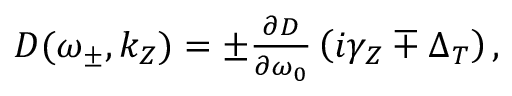<formula> <loc_0><loc_0><loc_500><loc_500>\begin{array} { r } { D ( \omega _ { \pm } , k _ { Z } ) = \pm \frac { \partial D } { \partial \omega _ { 0 } } \left ( i \gamma _ { Z } \mp \Delta _ { T } \right ) , } \end{array}</formula> 